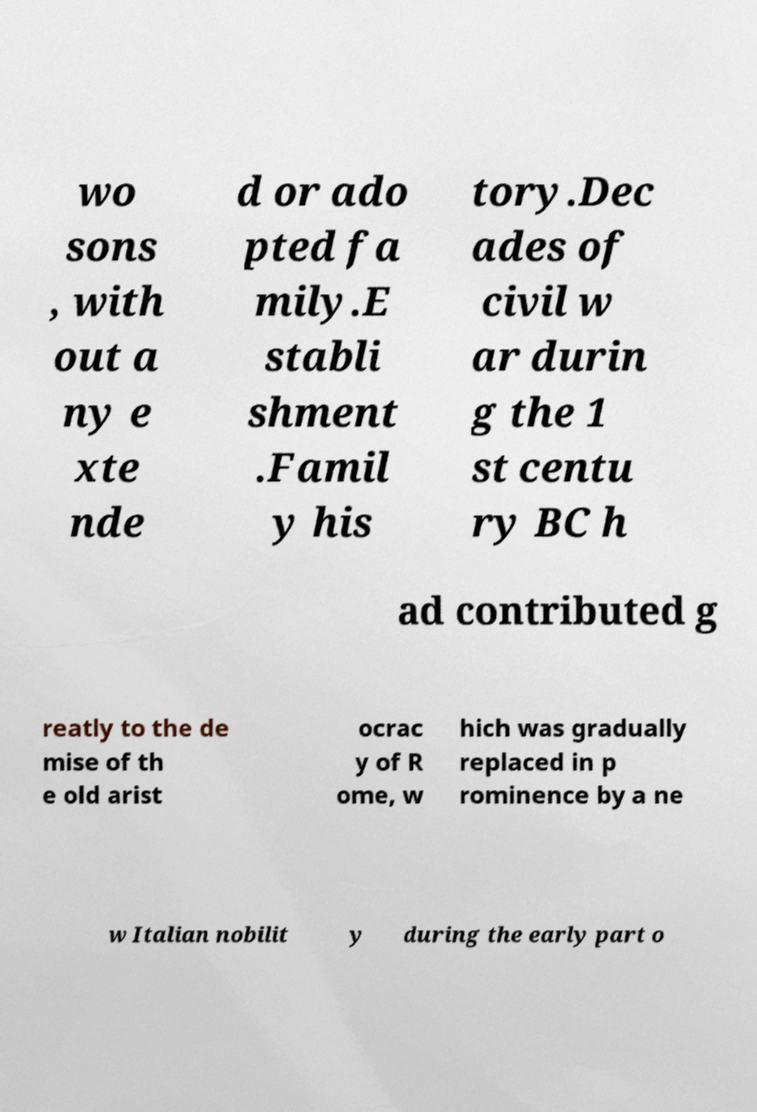Can you accurately transcribe the text from the provided image for me? wo sons , with out a ny e xte nde d or ado pted fa mily.E stabli shment .Famil y his tory.Dec ades of civil w ar durin g the 1 st centu ry BC h ad contributed g reatly to the de mise of th e old arist ocrac y of R ome, w hich was gradually replaced in p rominence by a ne w Italian nobilit y during the early part o 